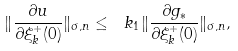Convert formula to latex. <formula><loc_0><loc_0><loc_500><loc_500>\| \frac { \partial u } { \partial \xi ^ { + } _ { k } ( 0 ) } \| _ { \sigma , n } \leq \ k _ { 1 } \| \frac { \partial g _ { * } } { \partial \xi ^ { + } _ { k } ( 0 ) } \| _ { \sigma , n } ,</formula> 